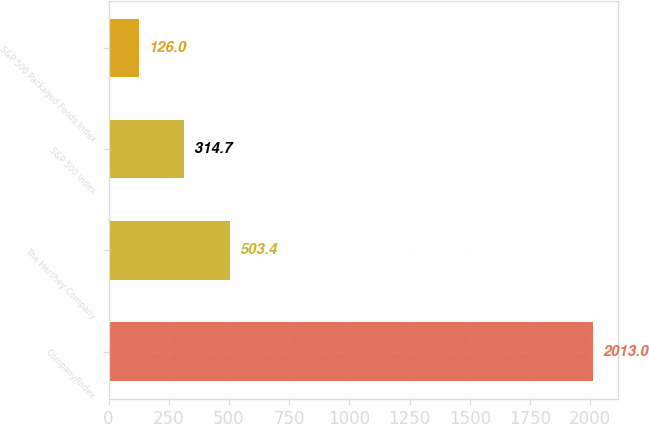Convert chart. <chart><loc_0><loc_0><loc_500><loc_500><bar_chart><fcel>Company/Index<fcel>The Hershey Company<fcel>S&P 500 Index<fcel>S&P 500 Packaged Foods Index<nl><fcel>2013<fcel>503.4<fcel>314.7<fcel>126<nl></chart> 